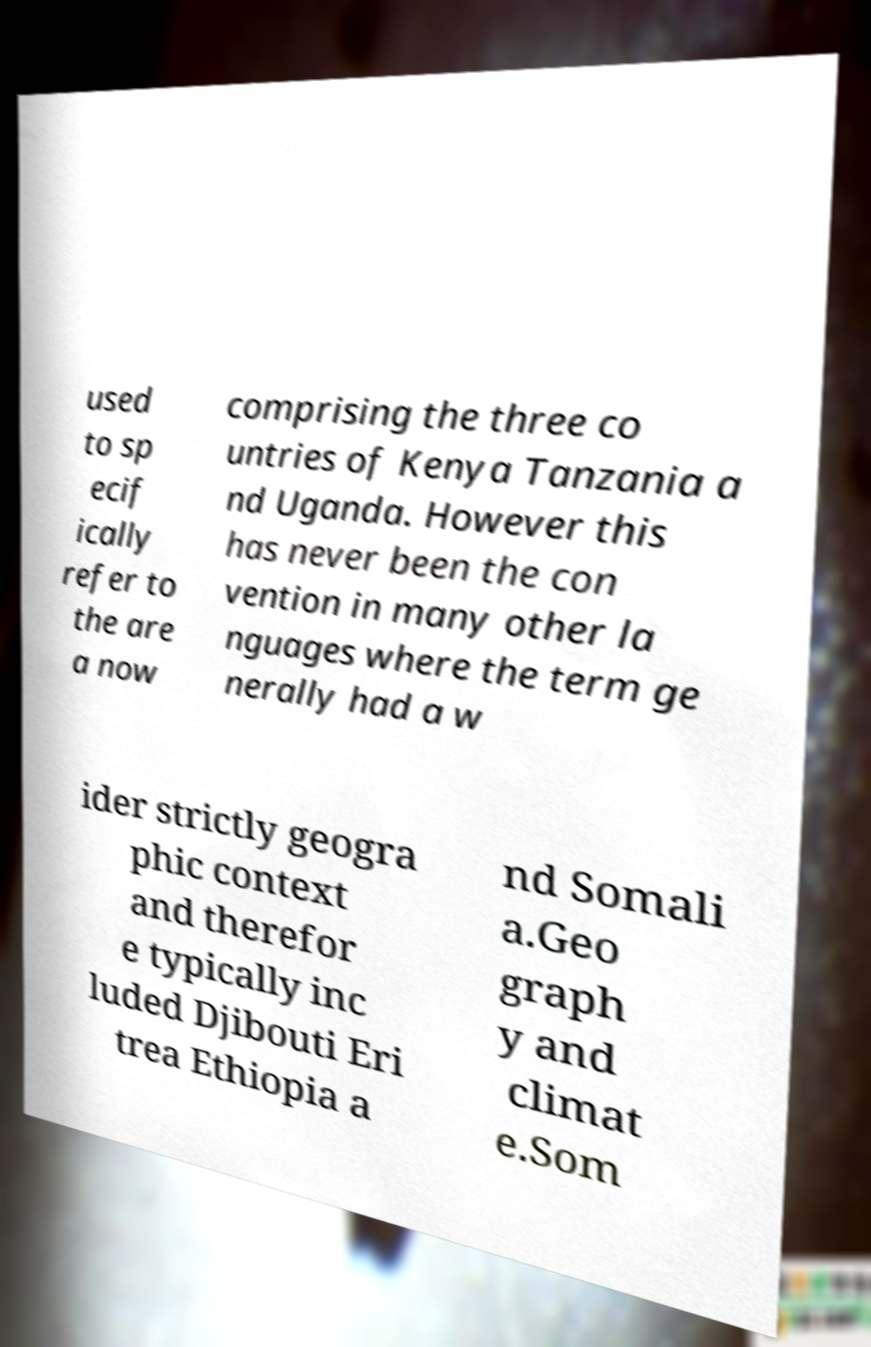Please read and relay the text visible in this image. What does it say? used to sp ecif ically refer to the are a now comprising the three co untries of Kenya Tanzania a nd Uganda. However this has never been the con vention in many other la nguages where the term ge nerally had a w ider strictly geogra phic context and therefor e typically inc luded Djibouti Eri trea Ethiopia a nd Somali a.Geo graph y and climat e.Som 